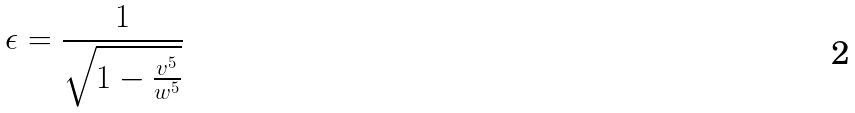Convert formula to latex. <formula><loc_0><loc_0><loc_500><loc_500>\epsilon = \frac { 1 } { \sqrt { 1 - \frac { v ^ { 5 } } { w ^ { 5 } } } }</formula> 